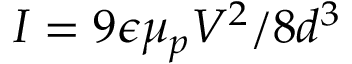<formula> <loc_0><loc_0><loc_500><loc_500>I = 9 \epsilon \mu _ { p } V ^ { 2 } / 8 d ^ { 3 }</formula> 